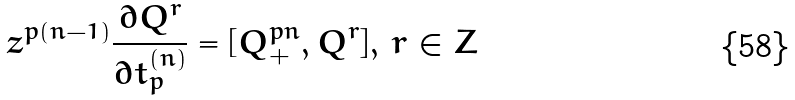<formula> <loc_0><loc_0><loc_500><loc_500>z ^ { p ( n - 1 ) } \frac { \partial Q ^ { r } } { \partial t _ { p } ^ { ( n ) } } = [ Q _ { + } ^ { p n } , Q ^ { r } ] , \, r \in { Z }</formula> 